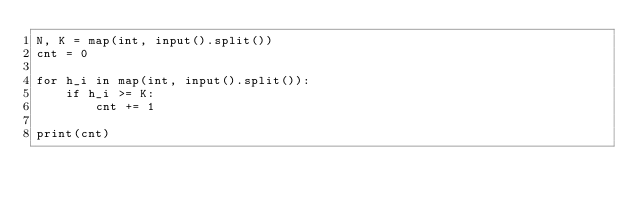<code> <loc_0><loc_0><loc_500><loc_500><_Python_>N, K = map(int, input().split())
cnt = 0

for h_i in map(int, input().split()):
    if h_i >= K:
        cnt += 1

print(cnt)</code> 